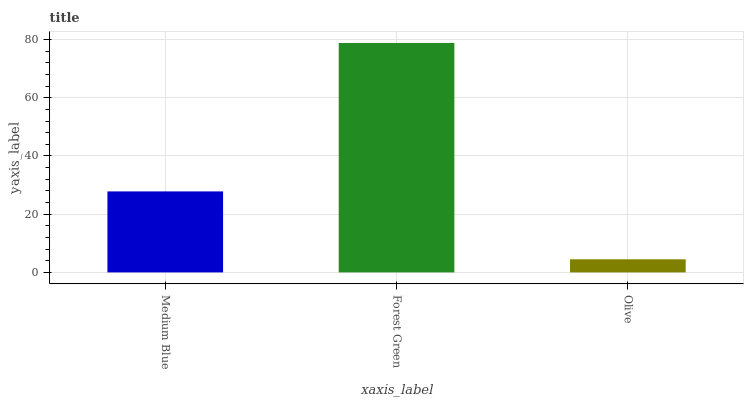Is Forest Green the minimum?
Answer yes or no. No. Is Olive the maximum?
Answer yes or no. No. Is Forest Green greater than Olive?
Answer yes or no. Yes. Is Olive less than Forest Green?
Answer yes or no. Yes. Is Olive greater than Forest Green?
Answer yes or no. No. Is Forest Green less than Olive?
Answer yes or no. No. Is Medium Blue the high median?
Answer yes or no. Yes. Is Medium Blue the low median?
Answer yes or no. Yes. Is Olive the high median?
Answer yes or no. No. Is Olive the low median?
Answer yes or no. No. 